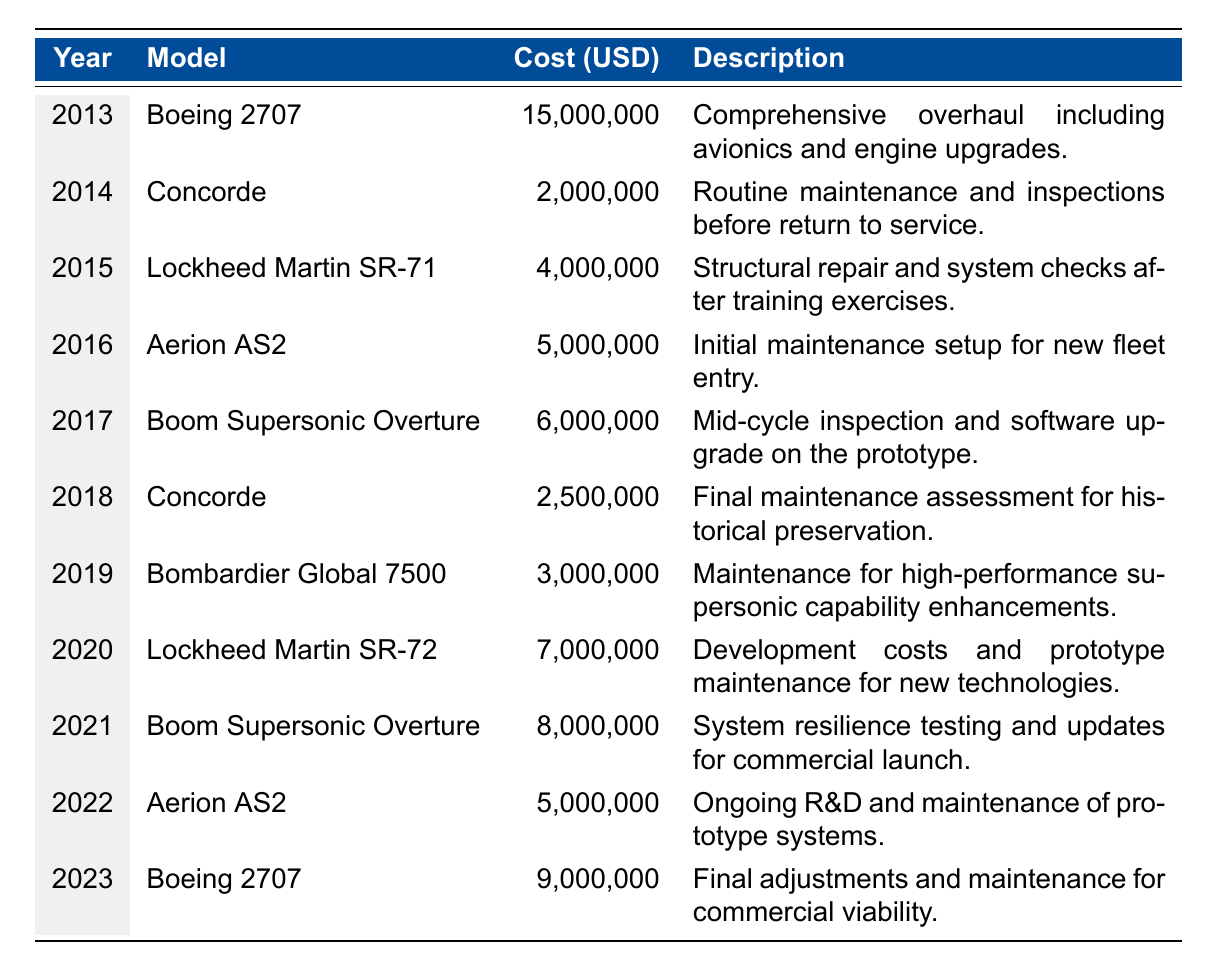What was the maintenance cost for the Concorde in 2018? The table shows that in 2018, the Concorde had a maintenance cost of 2,500,000 USD.
Answer: 2,500,000 USD Which supersonic jet incurred the highest maintenance cost in 2013? According to the table, the Boeing 2707 had the highest maintenance cost in 2013, which was 15,000,000 USD.
Answer: Boeing 2707 What is the total maintenance cost for the Aerion AS2 over the years listed? The table provides the Aerion AS2 maintenance costs for 2016 (5,000,000), and 2022 (5,000,000). Adding these together gives 5,000,000 + 5,000,000 = 10,000,000 USD.
Answer: 10,000,000 USD Was the maintenance cost for the Lockheed Martin SR-71 in 2015 higher than for the Bombardier Global 7500 in 2019? The table indicates that the maintenance cost for Lockheed Martin SR-71 in 2015 was 4,000,000 USD, while the Bombardier Global 7500 in 2019 was 3,000,000 USD. Since 4,000,000 is greater than 3,000,000, the statement is true.
Answer: Yes What was the average maintenance cost for the Boom Supersonic Overture models listed in the table? The Boom Supersonic Overture appears in 2017 with a cost of 6,000,000 USD and in 2021 with a cost of 8,000,000 USD. To find the average, sum these costs: 6,000,000 + 8,000,000 = 14,000,000. Then divide by 2 (the number of entries): 14,000,000 / 2 = 7,000,000 USD.
Answer: 7,000,000 USD How much did the Lockheed Martin SR-72 cost for maintenance in 2020? According to the table, the Lockheed Martin SR-72 incurred a maintenance cost of 7,000,000 USD in 2020.
Answer: 7,000,000 USD Which year had the second highest maintenance cost, and what was that cost? By examining the table, the highest cost was in 2013 (15,000,000 USD for the Boeing 2707), and the second highest cost is in 2021 (8,000,000 USD for the Boom Supersonic Overture).
Answer: 2021, 8,000,000 USD Is the maintenance cost trend increasing over the years for the supersonic jets listed? By reviewing the data, we can see that while some years show fluctuations, the overall trend from 2013 to 2023 shows an increase in maintenance costs. This indicates a general upward trend, especially in recent years.
Answer: Yes 